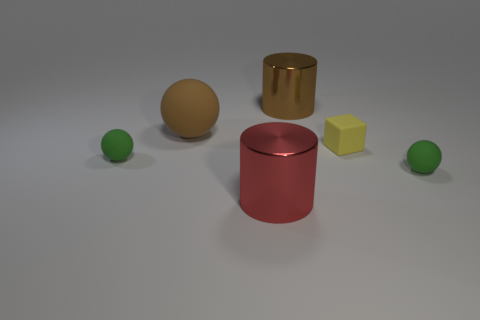Subtract all yellow cubes. How many green spheres are left? 2 Subtract 1 spheres. How many spheres are left? 2 Add 3 large blue metallic spheres. How many objects exist? 9 Subtract all cubes. How many objects are left? 5 Subtract 0 blue blocks. How many objects are left? 6 Subtract all matte objects. Subtract all tiny blocks. How many objects are left? 1 Add 3 matte balls. How many matte balls are left? 6 Add 3 small matte things. How many small matte things exist? 6 